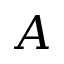Convert formula to latex. <formula><loc_0><loc_0><loc_500><loc_500>A</formula> 